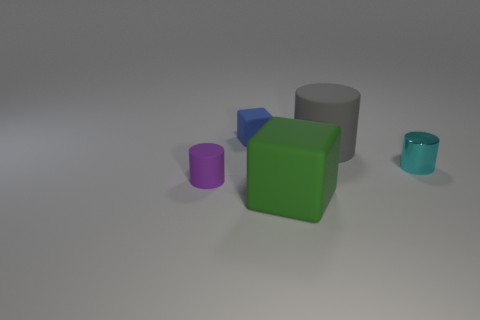What size is the blue block that is made of the same material as the gray cylinder?
Provide a short and direct response. Small. There is a small cylinder that is behind the small cylinder in front of the cyan cylinder; what number of large matte things are in front of it?
Provide a short and direct response. 1. There is a big rubber cube; does it have the same color as the cylinder in front of the tiny metal cylinder?
Your answer should be compact. No. The cylinder behind the object that is to the right of the cylinder behind the small cyan metallic cylinder is made of what material?
Make the answer very short. Rubber. Do the large object that is on the left side of the large gray rubber thing and the blue thing have the same shape?
Give a very brief answer. Yes. There is a block that is in front of the small rubber cylinder; what is its material?
Ensure brevity in your answer.  Rubber. How many rubber objects are either large cyan things or cubes?
Make the answer very short. 2. Is there a gray object that has the same size as the shiny cylinder?
Your answer should be very brief. No. Is the number of cyan metallic objects that are left of the gray thing greater than the number of large cylinders?
Give a very brief answer. No. What number of big objects are cyan matte spheres or gray objects?
Offer a terse response. 1. 